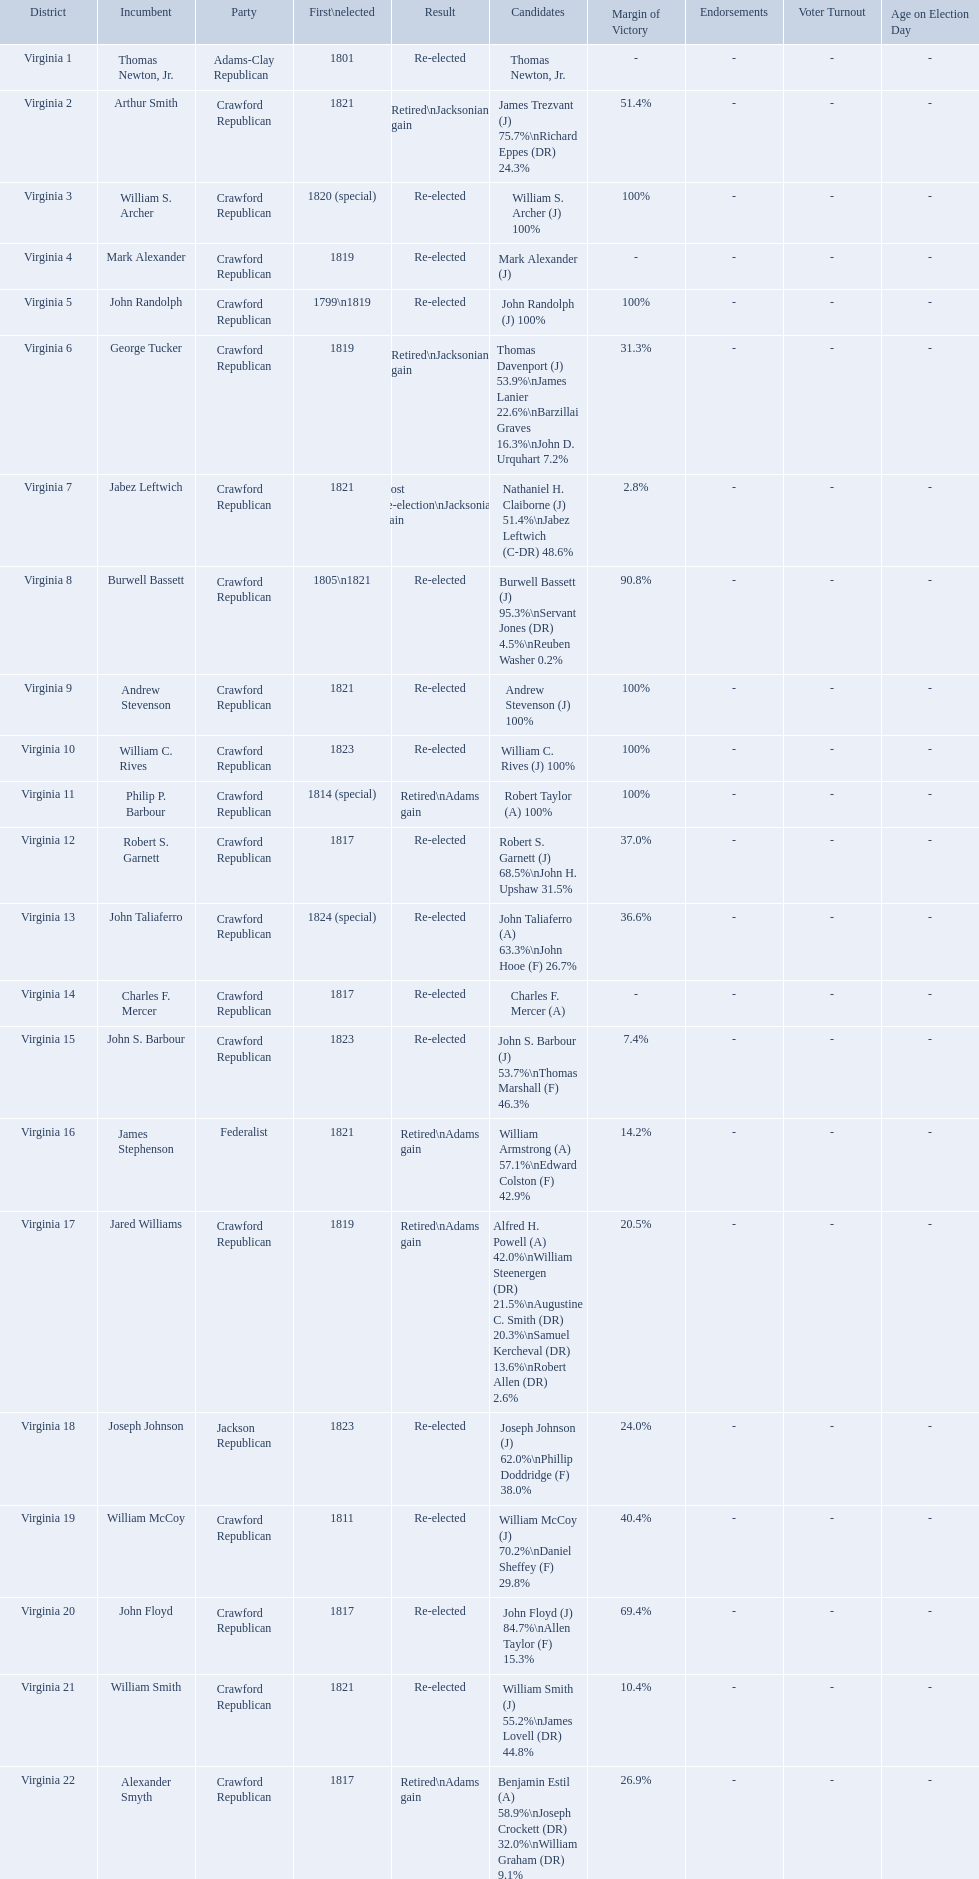Who were the incumbents of the 1824 united states house of representatives elections? Thomas Newton, Jr., Arthur Smith, William S. Archer, Mark Alexander, John Randolph, George Tucker, Jabez Leftwich, Burwell Bassett, Andrew Stevenson, William C. Rives, Philip P. Barbour, Robert S. Garnett, John Taliaferro, Charles F. Mercer, John S. Barbour, James Stephenson, Jared Williams, Joseph Johnson, William McCoy, John Floyd, William Smith, Alexander Smyth. And who were the candidates? Thomas Newton, Jr., James Trezvant (J) 75.7%\nRichard Eppes (DR) 24.3%, William S. Archer (J) 100%, Mark Alexander (J), John Randolph (J) 100%, Thomas Davenport (J) 53.9%\nJames Lanier 22.6%\nBarzillai Graves 16.3%\nJohn D. Urquhart 7.2%, Nathaniel H. Claiborne (J) 51.4%\nJabez Leftwich (C-DR) 48.6%, Burwell Bassett (J) 95.3%\nServant Jones (DR) 4.5%\nReuben Washer 0.2%, Andrew Stevenson (J) 100%, William C. Rives (J) 100%, Robert Taylor (A) 100%, Robert S. Garnett (J) 68.5%\nJohn H. Upshaw 31.5%, John Taliaferro (A) 63.3%\nJohn Hooe (F) 26.7%, Charles F. Mercer (A), John S. Barbour (J) 53.7%\nThomas Marshall (F) 46.3%, William Armstrong (A) 57.1%\nEdward Colston (F) 42.9%, Alfred H. Powell (A) 42.0%\nWilliam Steenergen (DR) 21.5%\nAugustine C. Smith (DR) 20.3%\nSamuel Kercheval (DR) 13.6%\nRobert Allen (DR) 2.6%, Joseph Johnson (J) 62.0%\nPhillip Doddridge (F) 38.0%, William McCoy (J) 70.2%\nDaniel Sheffey (F) 29.8%, John Floyd (J) 84.7%\nAllen Taylor (F) 15.3%, William Smith (J) 55.2%\nJames Lovell (DR) 44.8%, Benjamin Estil (A) 58.9%\nJoseph Crockett (DR) 32.0%\nWilliam Graham (DR) 9.1%. What were the results of their elections? Re-elected, Retired\nJacksonian gain, Re-elected, Re-elected, Re-elected, Retired\nJacksonian gain, Lost re-election\nJacksonian gain, Re-elected, Re-elected, Re-elected, Retired\nAdams gain, Re-elected, Re-elected, Re-elected, Re-elected, Retired\nAdams gain, Retired\nAdams gain, Re-elected, Re-elected, Re-elected, Re-elected, Retired\nAdams gain. And which jacksonian won over 76%? Arthur Smith. 